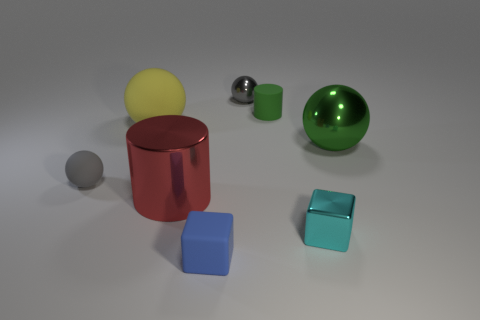Does the tiny shiny ball have the same color as the small matte sphere?
Your response must be concise. Yes. Is the material of the gray object right of the metallic cylinder the same as the cylinder that is left of the blue matte block?
Your answer should be very brief. Yes. There is a gray object left of the gray object behind the large shiny sphere; what size is it?
Ensure brevity in your answer.  Small. What is the material of the large yellow object that is the same shape as the gray shiny thing?
Your answer should be compact. Rubber. There is a small shiny thing that is in front of the large red shiny thing; is it the same shape as the small object on the left side of the small blue object?
Your answer should be compact. No. Are there more big red cylinders than large brown matte objects?
Ensure brevity in your answer.  Yes. What is the size of the blue thing?
Give a very brief answer. Small. How many other objects are the same color as the large shiny sphere?
Provide a succinct answer. 1. Does the green object on the right side of the cyan object have the same material as the big yellow sphere?
Ensure brevity in your answer.  No. Are there fewer small blue rubber objects on the left side of the green matte object than small blue blocks right of the blue rubber object?
Make the answer very short. No. 